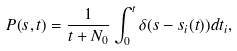<formula> <loc_0><loc_0><loc_500><loc_500>P ( s , t ) = \frac { 1 } { t + N _ { 0 } } \int _ { 0 } ^ { t } \delta ( s - s _ { i } ( t ) ) d t _ { i } ,</formula> 